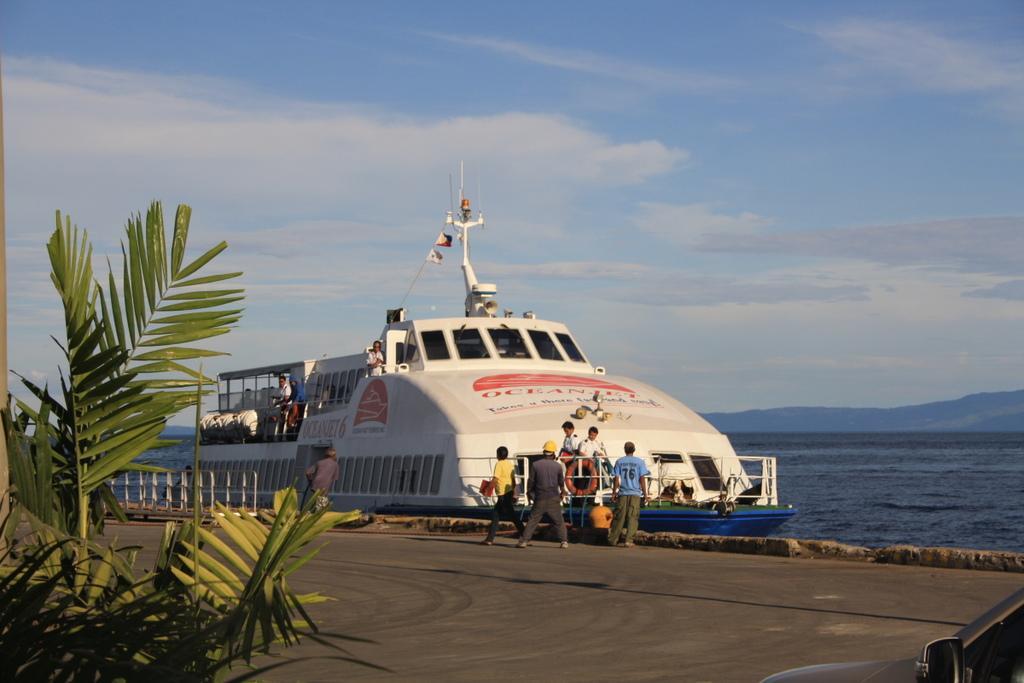Can you describe this image briefly? In this picture I can observe a ship floating on the water. There are some people on the land. On the left side I can observe some plants. In the background there is an ocean and some clouds in the sky. 